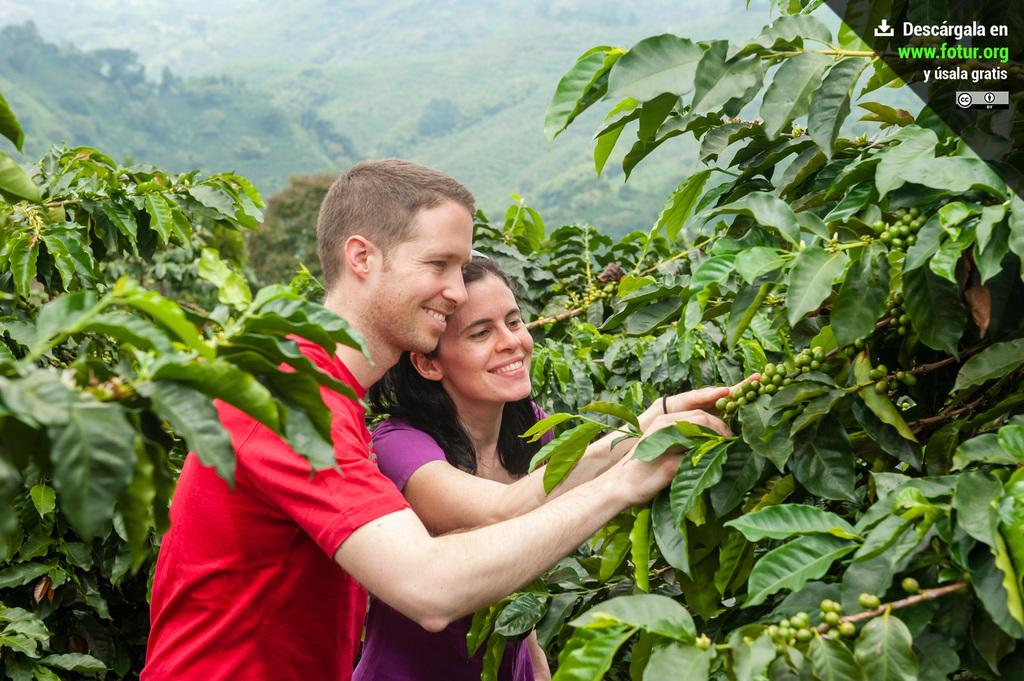How many people are in the image? There are two people in the image. What colors are the dresses of the people in the image? One person is wearing a red dress, and the other person is wearing a purple dress. Where are the people standing in relation to the plants? The people are standing in-between plants. What can be seen in the background of the image? There are mountains visible in the background of the image. What type of impulse can be seen affecting the toe of the person in the red dress? There is no impulse or toe visible in the image; it only shows two people standing between plants with mountains in the background. 